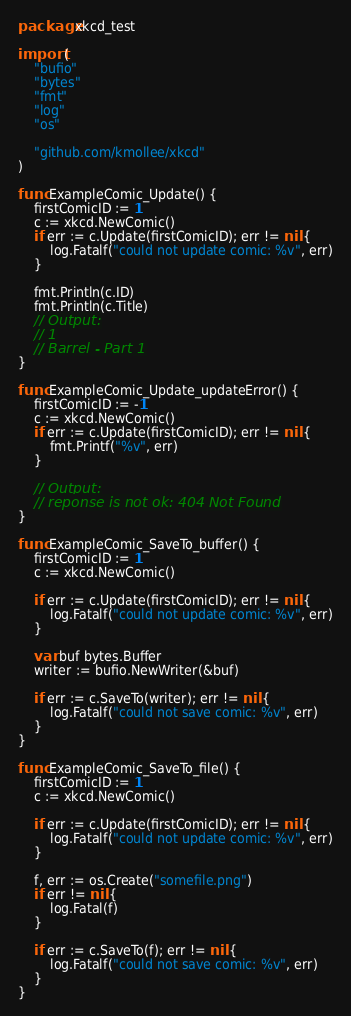<code> <loc_0><loc_0><loc_500><loc_500><_Go_>package xkcd_test

import (
	"bufio"
	"bytes"
	"fmt"
	"log"
	"os"

	"github.com/kmollee/xkcd"
)

func ExampleComic_Update() {
	firstComicID := 1
	c := xkcd.NewComic()
	if err := c.Update(firstComicID); err != nil {
		log.Fatalf("could not update comic: %v", err)
	}

	fmt.Println(c.ID)
	fmt.Println(c.Title)
	// Output:
	// 1
	// Barrel - Part 1
}

func ExampleComic_Update_updateError() {
	firstComicID := -1
	c := xkcd.NewComic()
	if err := c.Update(firstComicID); err != nil {
		fmt.Printf("%v", err)
	}

	// Output:
	// reponse is not ok: 404 Not Found
}

func ExampleComic_SaveTo_buffer() {
	firstComicID := 1
	c := xkcd.NewComic()

	if err := c.Update(firstComicID); err != nil {
		log.Fatalf("could not update comic: %v", err)
	}

	var buf bytes.Buffer
	writer := bufio.NewWriter(&buf)

	if err := c.SaveTo(writer); err != nil {
		log.Fatalf("could not save comic: %v", err)
	}
}

func ExampleComic_SaveTo_file() {
	firstComicID := 1
	c := xkcd.NewComic()

	if err := c.Update(firstComicID); err != nil {
		log.Fatalf("could not update comic: %v", err)
	}

	f, err := os.Create("somefile.png")
	if err != nil {
		log.Fatal(f)
	}

	if err := c.SaveTo(f); err != nil {
		log.Fatalf("could not save comic: %v", err)
	}
}
</code> 